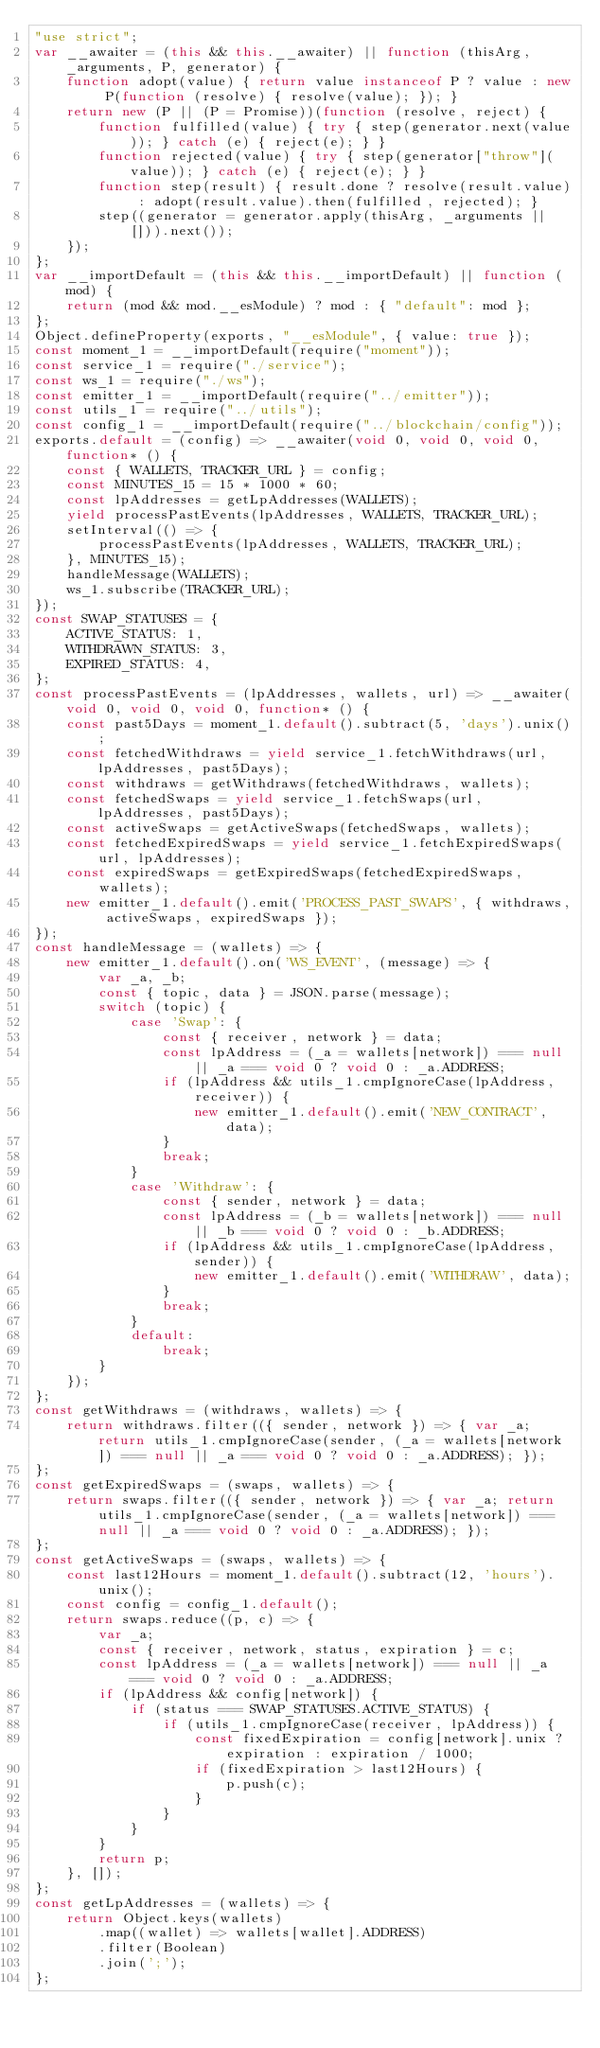Convert code to text. <code><loc_0><loc_0><loc_500><loc_500><_JavaScript_>"use strict";
var __awaiter = (this && this.__awaiter) || function (thisArg, _arguments, P, generator) {
    function adopt(value) { return value instanceof P ? value : new P(function (resolve) { resolve(value); }); }
    return new (P || (P = Promise))(function (resolve, reject) {
        function fulfilled(value) { try { step(generator.next(value)); } catch (e) { reject(e); } }
        function rejected(value) { try { step(generator["throw"](value)); } catch (e) { reject(e); } }
        function step(result) { result.done ? resolve(result.value) : adopt(result.value).then(fulfilled, rejected); }
        step((generator = generator.apply(thisArg, _arguments || [])).next());
    });
};
var __importDefault = (this && this.__importDefault) || function (mod) {
    return (mod && mod.__esModule) ? mod : { "default": mod };
};
Object.defineProperty(exports, "__esModule", { value: true });
const moment_1 = __importDefault(require("moment"));
const service_1 = require("./service");
const ws_1 = require("./ws");
const emitter_1 = __importDefault(require("../emitter"));
const utils_1 = require("../utils");
const config_1 = __importDefault(require("../blockchain/config"));
exports.default = (config) => __awaiter(void 0, void 0, void 0, function* () {
    const { WALLETS, TRACKER_URL } = config;
    const MINUTES_15 = 15 * 1000 * 60;
    const lpAddresses = getLpAddresses(WALLETS);
    yield processPastEvents(lpAddresses, WALLETS, TRACKER_URL);
    setInterval(() => {
        processPastEvents(lpAddresses, WALLETS, TRACKER_URL);
    }, MINUTES_15);
    handleMessage(WALLETS);
    ws_1.subscribe(TRACKER_URL);
});
const SWAP_STATUSES = {
    ACTIVE_STATUS: 1,
    WITHDRAWN_STATUS: 3,
    EXPIRED_STATUS: 4,
};
const processPastEvents = (lpAddresses, wallets, url) => __awaiter(void 0, void 0, void 0, function* () {
    const past5Days = moment_1.default().subtract(5, 'days').unix();
    const fetchedWithdraws = yield service_1.fetchWithdraws(url, lpAddresses, past5Days);
    const withdraws = getWithdraws(fetchedWithdraws, wallets);
    const fetchedSwaps = yield service_1.fetchSwaps(url, lpAddresses, past5Days);
    const activeSwaps = getActiveSwaps(fetchedSwaps, wallets);
    const fetchedExpiredSwaps = yield service_1.fetchExpiredSwaps(url, lpAddresses);
    const expiredSwaps = getExpiredSwaps(fetchedExpiredSwaps, wallets);
    new emitter_1.default().emit('PROCESS_PAST_SWAPS', { withdraws, activeSwaps, expiredSwaps });
});
const handleMessage = (wallets) => {
    new emitter_1.default().on('WS_EVENT', (message) => {
        var _a, _b;
        const { topic, data } = JSON.parse(message);
        switch (topic) {
            case 'Swap': {
                const { receiver, network } = data;
                const lpAddress = (_a = wallets[network]) === null || _a === void 0 ? void 0 : _a.ADDRESS;
                if (lpAddress && utils_1.cmpIgnoreCase(lpAddress, receiver)) {
                    new emitter_1.default().emit('NEW_CONTRACT', data);
                }
                break;
            }
            case 'Withdraw': {
                const { sender, network } = data;
                const lpAddress = (_b = wallets[network]) === null || _b === void 0 ? void 0 : _b.ADDRESS;
                if (lpAddress && utils_1.cmpIgnoreCase(lpAddress, sender)) {
                    new emitter_1.default().emit('WITHDRAW', data);
                }
                break;
            }
            default:
                break;
        }
    });
};
const getWithdraws = (withdraws, wallets) => {
    return withdraws.filter(({ sender, network }) => { var _a; return utils_1.cmpIgnoreCase(sender, (_a = wallets[network]) === null || _a === void 0 ? void 0 : _a.ADDRESS); });
};
const getExpiredSwaps = (swaps, wallets) => {
    return swaps.filter(({ sender, network }) => { var _a; return utils_1.cmpIgnoreCase(sender, (_a = wallets[network]) === null || _a === void 0 ? void 0 : _a.ADDRESS); });
};
const getActiveSwaps = (swaps, wallets) => {
    const last12Hours = moment_1.default().subtract(12, 'hours').unix();
    const config = config_1.default();
    return swaps.reduce((p, c) => {
        var _a;
        const { receiver, network, status, expiration } = c;
        const lpAddress = (_a = wallets[network]) === null || _a === void 0 ? void 0 : _a.ADDRESS;
        if (lpAddress && config[network]) {
            if (status === SWAP_STATUSES.ACTIVE_STATUS) {
                if (utils_1.cmpIgnoreCase(receiver, lpAddress)) {
                    const fixedExpiration = config[network].unix ? expiration : expiration / 1000;
                    if (fixedExpiration > last12Hours) {
                        p.push(c);
                    }
                }
            }
        }
        return p;
    }, []);
};
const getLpAddresses = (wallets) => {
    return Object.keys(wallets)
        .map((wallet) => wallets[wallet].ADDRESS)
        .filter(Boolean)
        .join(';');
};
</code> 